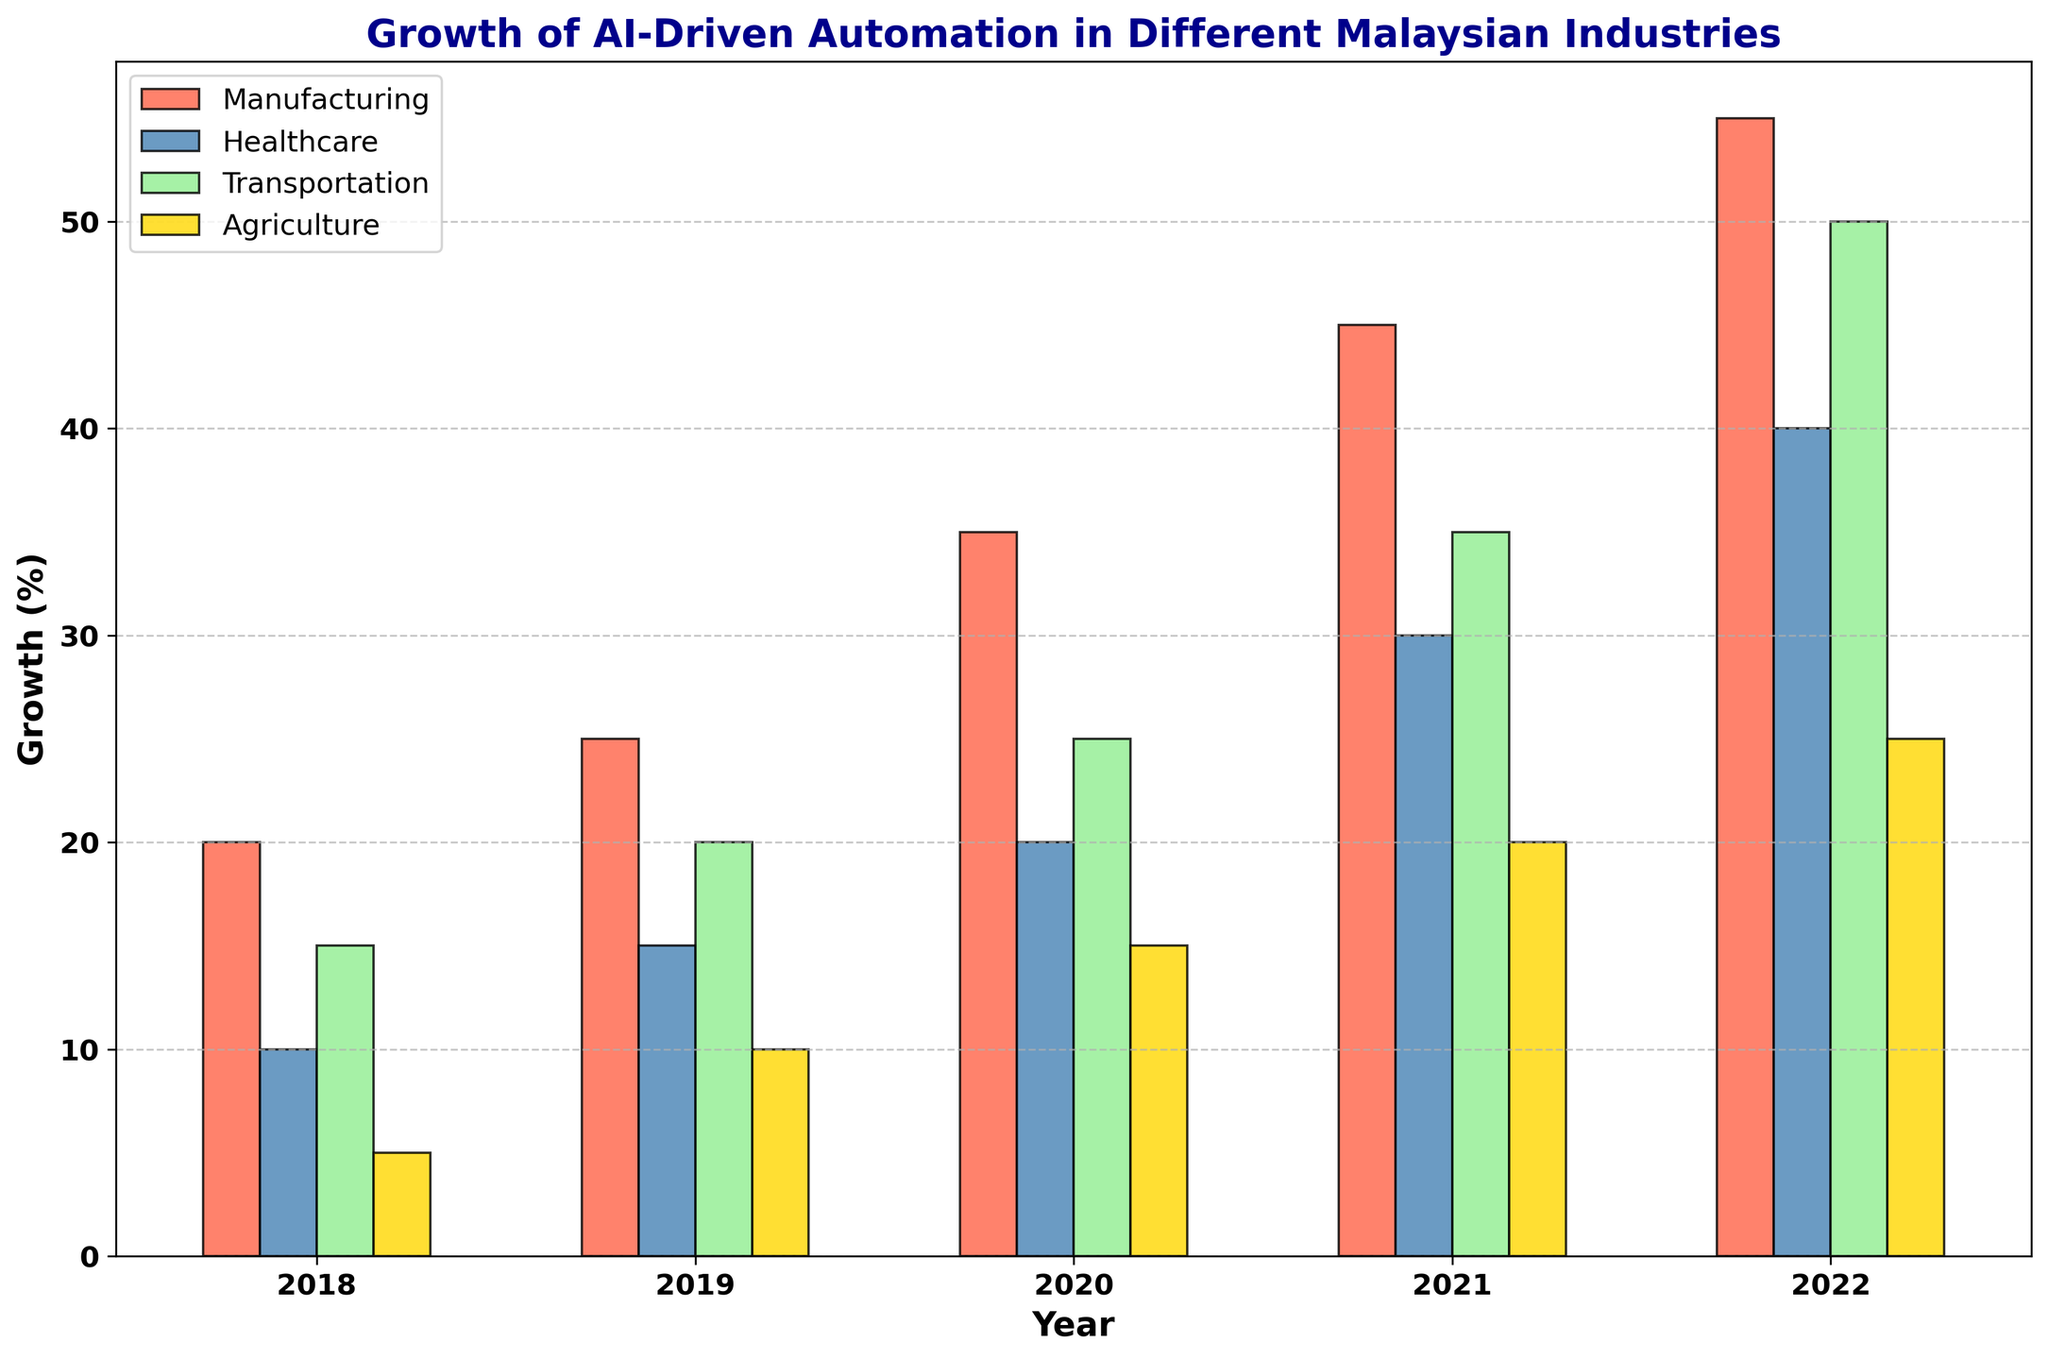Which industry showed the most growth in AI-driven automation from 2018 to 2022? We need to look at the total increase from 2018 to 2022 for each industry. Manufacturing grew from 20% to 55% (35% increase), Healthcare from 10% to 40% (30% increase), Transportation from 15% to 50% (35% increase), and Agriculture from 5% to 25% (20% increase). Manufacturing and Transportation both show the highest growth of 35%.
Answer: Manufacturing and Transportation Which year had the highest overall percentage of AI-driven automation across all industries? We add up the percentages for all industries for each year and compare the totals. Total for 2018: 50%, 2019: 70%, 2020: 95%, 2021: 130%, 2022: 170%. The highest total percentage is in 2022.
Answer: 2022 Between 2018 and 2022, which industry had the smallest increase in AI-driven automation? Calculate the difference in percentages between 2018 and 2022 for each industry. Manufacturing: 35%, Healthcare: 30%, Transportation: 35%, Agriculture: 20%. Agriculture had the smallest increase of 20%.
Answer: Agriculture By how much did AI-driven automation in the Healthcare sector increase from 2019 to 2022? Subtract the 2019 value from the 2022 value for Healthcare. 2022 value: 40%, 2019 value: 15%. The increase is 40% - 15% = 25%.
Answer: 25% In 2020, which industry had a level of AI-driven automation equal to the level that Transportation had in 2019? From the figure, Transportation had 20% in 2019. In 2020, Healthcare also had 20%.
Answer: Healthcare Compare the growth of AI-driven automation in the Manufacturing and Agriculture sectors between 2020 and 2022. By how much did each sector grow? For Manufacturing, the value in 2020 is 35% and in 2022 is 55%, a growth of 55% - 35% = 20%. For Agriculture, the value in 2020 is 15% and in 2022 is 25%, a growth of 25% - 15% = 10%.
Answer: Manufacturing grew by 20%, Agriculture by 10% Which year saw the largest single-year increase in AI-driven automation for the Transportation industry? Look at the yearly increases for Transportation. 2018 to 2019: 5%, 2019 to 2020: 5%, 2020 to 2021: 10%, 2021 to 2022: 15%. The largest single-year increase is from 2021 to 2022 with 15%.
Answer: 2021 to 2022 On average, what was the yearly increase in AI-driven automation for the Agriculture industry from 2018 to 2022? Calculate the difference from 2018 to 2022, then divide by the number of years (25% - 5% = 20%, and there are 4 intervals: 2018-2019, 2019-2020, etc.). Average increase is 20% / 4 = 5%.
Answer: 5% In which year did all industries together have exactly 70% AI-driven automation? Add the percentages for each year: only in 2019 (Manufacturing: 25%, Healthcare: 15%, Transportation: 20%, Agriculture: 10%) does the total sum up to 70%.
Answer: 2019 